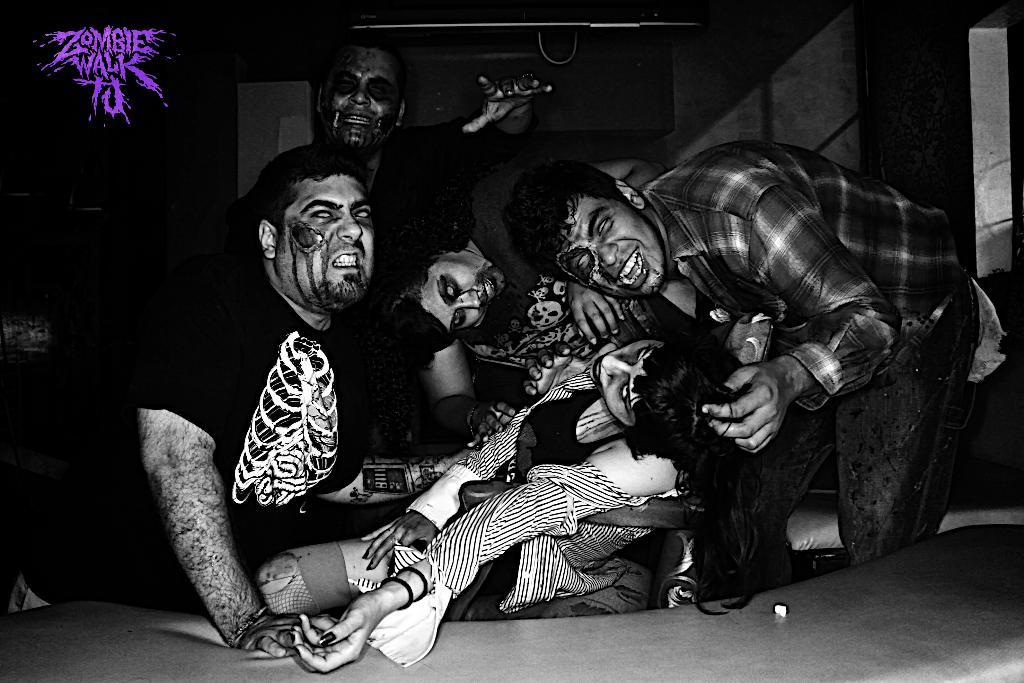Who is present in the image? There are people in the image. What are the people wearing in the image? The people are dressed as zombies. What are the people doing in the image? The people are posing for the camera. What type of net can be seen in the image? There is no net present in the image. Is there any crime being committed in the image? There is no indication of any crime being committed in the image. 